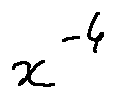Convert formula to latex. <formula><loc_0><loc_0><loc_500><loc_500>x ^ { - 4 }</formula> 